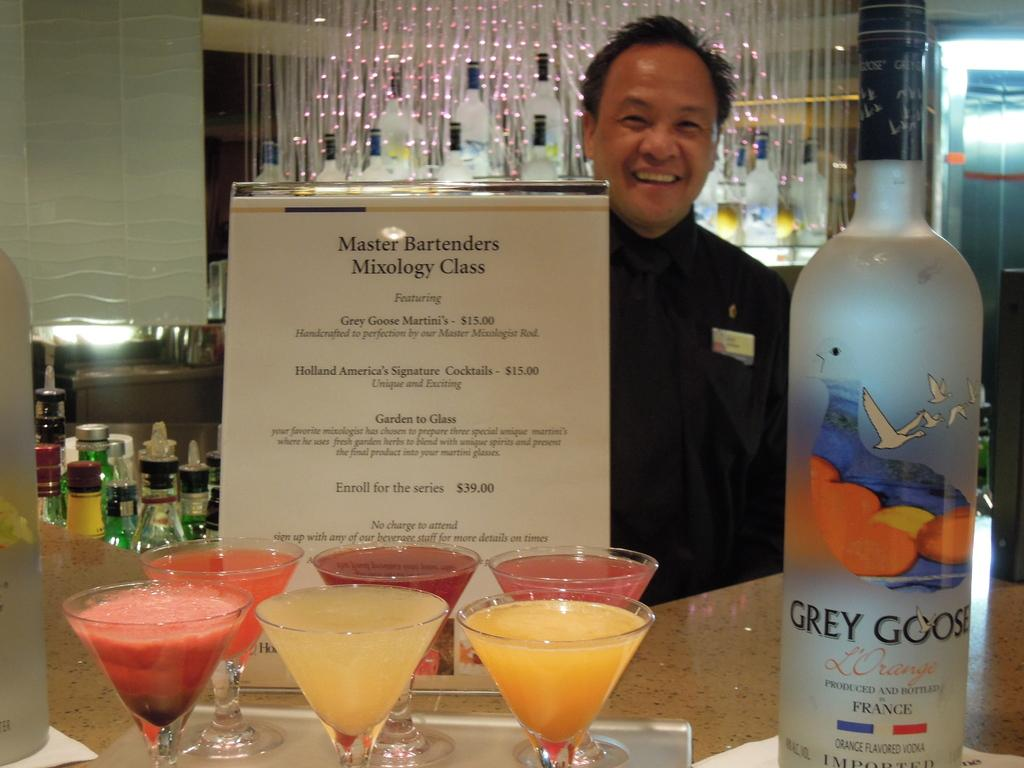<image>
Present a compact description of the photo's key features. One of the drinks the Master Bartender's Mixology Class features is a Grey Goose Martini. 